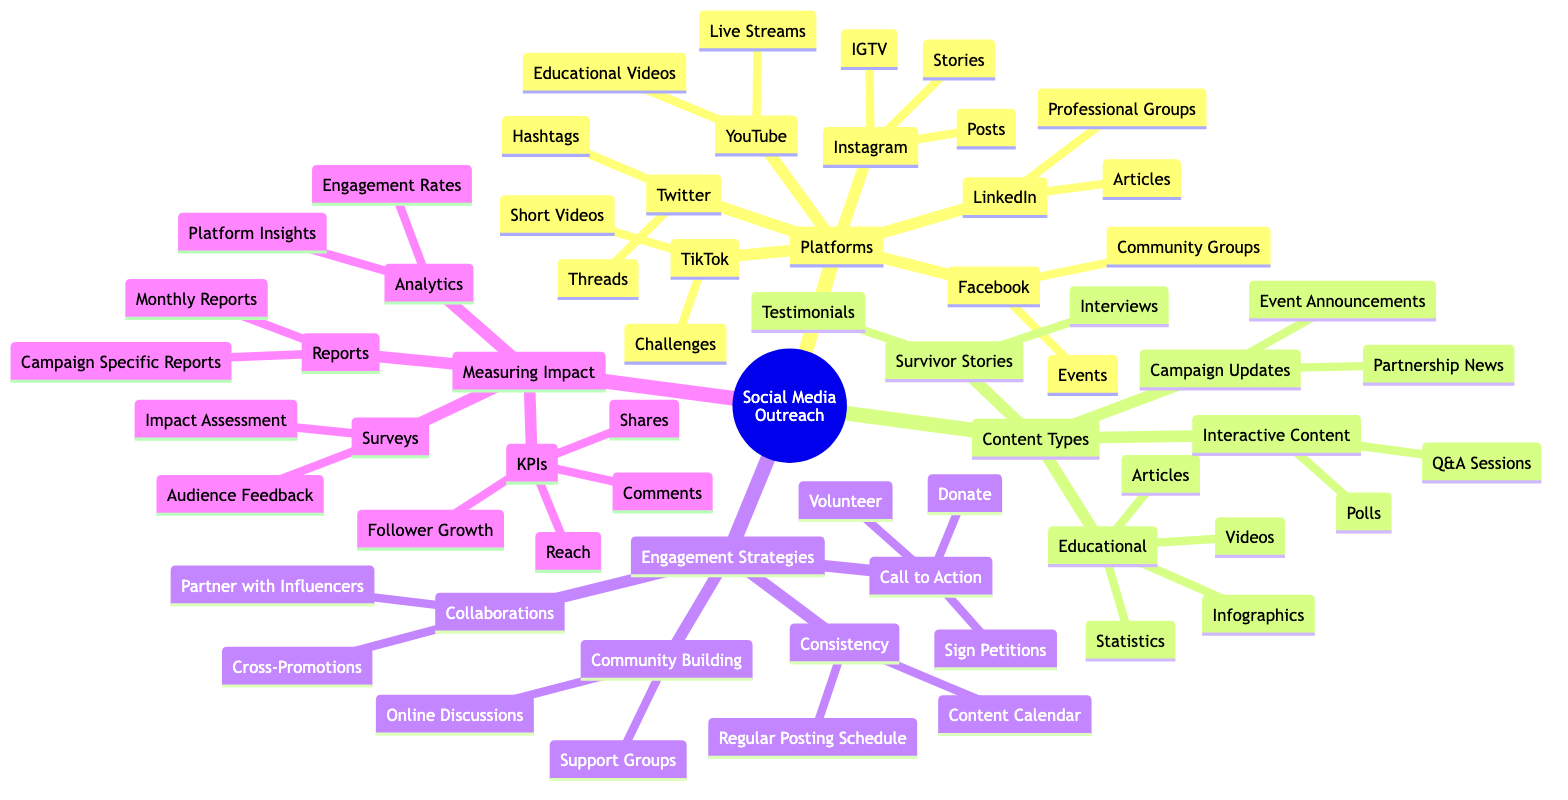What are the platforms used in social media outreach? The diagram outlines six platforms used in social media outreach: Facebook, Twitter, Instagram, TikTok, LinkedIn, and YouTube.
Answer: Facebook, Twitter, Instagram, TikTok, LinkedIn, YouTube How many content types are listed in the diagram? The diagram presents four main content types: Educational, Survivor Stories, Campaign Updates, and Interactive Content. This means a total of four distinct categories.
Answer: 4 What engagement strategy involves collaborating with influencers? The collaboration strategy mentioned in the diagram specifies the action "Partner with Influencers" under the Engagement Strategies section.
Answer: Partner with Influencers Which platform is associated with IGTV? The associated platform for IGTV, as indicated in the diagram, is Instagram.
Answer: Instagram What measure is used to assess audience feedback? The diagram describes 'Surveys' as revealing 'Audience Feedback' under the Measuring Impact section, which indicates this is the method of assessment.
Answer: Surveys What is one example of educational content? The diagram lists several examples of educational content, one specifically being 'Infographics,' which clearly labels one type of educational content.
Answer: Infographics How many types of campaigns are specifically named under Campaign Updates? The diagram specifies two types under Campaign Updates: Event Announcements and Partnership News, leading to a total of two types.
Answer: 2 What is the purpose of consistency in engagement strategies? The 'Consistency' engagement strategy identifies "Regular Posting Schedule" and "Content Calendar," indicating that the purpose is to maintain a structured approach to posting.
Answer: Regular Posting Schedule, Content Calendar How do you measure follower growth in social media campaigns? 'KPIs' are used to track 'Follower Growth' as indicated in the Measuring Impact section, showing how audience metrics are evaluated.
Answer: KPIs 